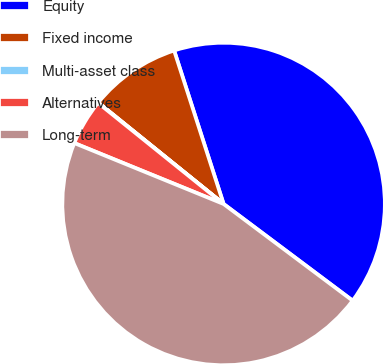Convert chart to OTSL. <chart><loc_0><loc_0><loc_500><loc_500><pie_chart><fcel>Equity<fcel>Fixed income<fcel>Multi-asset class<fcel>Alternatives<fcel>Long-term<nl><fcel>40.19%<fcel>9.21%<fcel>0.04%<fcel>4.62%<fcel>45.93%<nl></chart> 